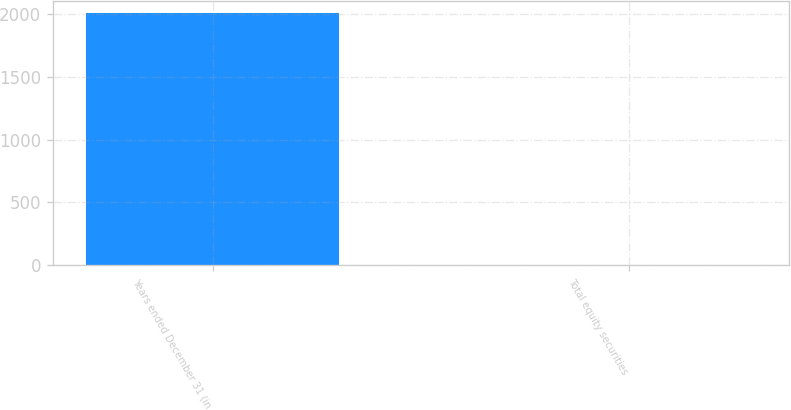Convert chart to OTSL. <chart><loc_0><loc_0><loc_500><loc_500><bar_chart><fcel>Years ended December 31 (in<fcel>Total equity securities<nl><fcel>2004<fcel>0.3<nl></chart> 